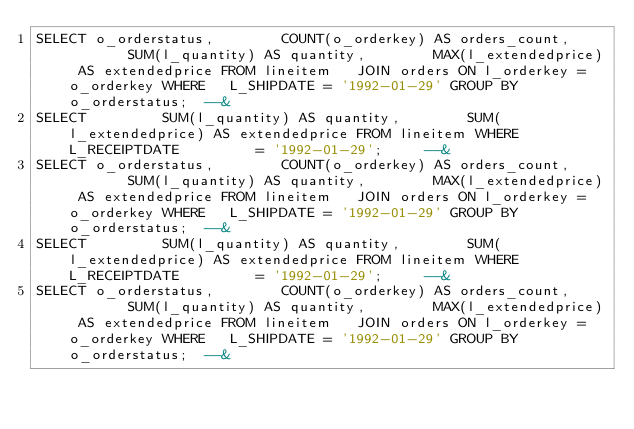Convert code to text. <code><loc_0><loc_0><loc_500><loc_500><_SQL_>SELECT o_orderstatus,        COUNT(o_orderkey) AS orders_count,        SUM(l_quantity) AS quantity,        MAX(l_extendedprice) AS extendedprice FROM lineitem   JOIN orders ON l_orderkey = o_orderkey WHERE   L_SHIPDATE = '1992-01-29' GROUP BY o_orderstatus;  --& 
SELECT         SUM(l_quantity) AS quantity,        SUM(l_extendedprice) AS extendedprice FROM lineitem WHERE   L_RECEIPTDATE         = '1992-01-29';     --&
SELECT o_orderstatus,        COUNT(o_orderkey) AS orders_count,        SUM(l_quantity) AS quantity,        MAX(l_extendedprice) AS extendedprice FROM lineitem   JOIN orders ON l_orderkey = o_orderkey WHERE   L_SHIPDATE = '1992-01-29' GROUP BY o_orderstatus;  --& 
SELECT         SUM(l_quantity) AS quantity,        SUM(l_extendedprice) AS extendedprice FROM lineitem WHERE   L_RECEIPTDATE         = '1992-01-29';     --&
SELECT o_orderstatus,        COUNT(o_orderkey) AS orders_count,        SUM(l_quantity) AS quantity,        MAX(l_extendedprice) AS extendedprice FROM lineitem   JOIN orders ON l_orderkey = o_orderkey WHERE   L_SHIPDATE = '1992-01-29' GROUP BY o_orderstatus;  --& </code> 